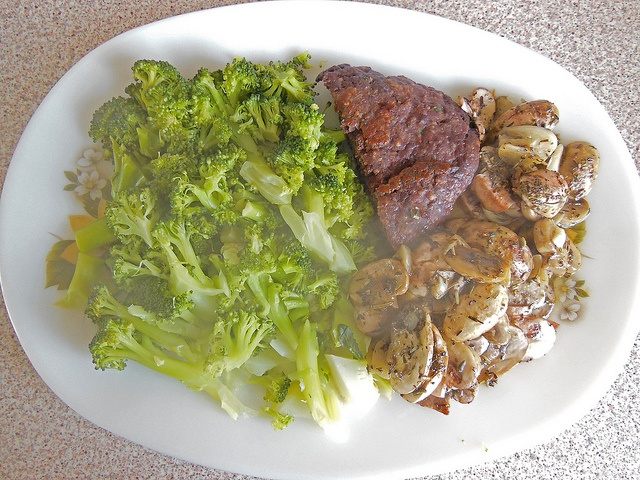Describe the objects in this image and their specific colors. I can see bowl in white, darkgray, and olive tones and broccoli in darkgray and olive tones in this image. 